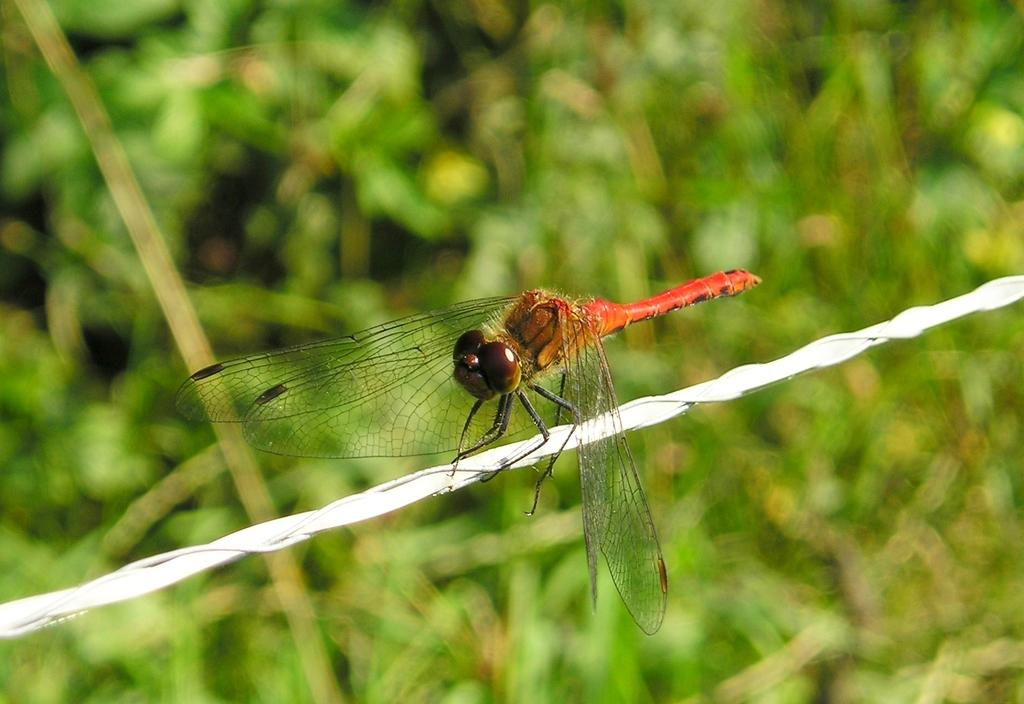What type of creature is present in the image? There is an insect in the image. What is the insect sitting on? The insect is on a white rope. Can you describe the background of the image? The background of the image is blurred. What type of cabbage is being held by the girl in the image? There is no girl or cabbage present in the image; it features an insect on a white rope with a blurred background. 